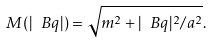Convert formula to latex. <formula><loc_0><loc_0><loc_500><loc_500>M ( | \ B q | ) = \sqrt { m ^ { 2 } + | \ B q | ^ { 2 } / a ^ { 2 } } .</formula> 